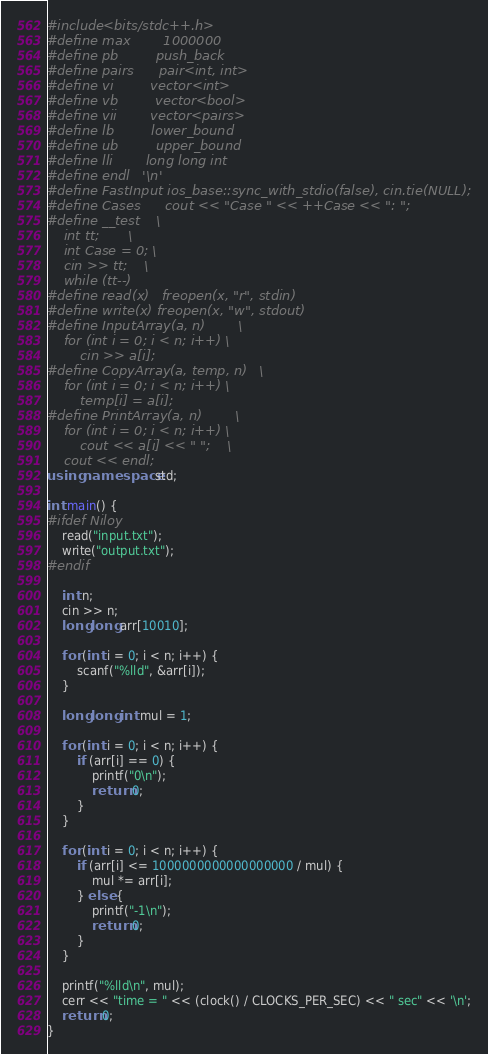<code> <loc_0><loc_0><loc_500><loc_500><_C++_>#include <bits/stdc++.h>
#define max		  1000000
#define pb		  push_back
#define pairs	  pair<int, int>
#define vi		  vector<int>
#define vb		  vector<bool>
#define vii		  vector<pairs>
#define lb		  lower_bound
#define ub		  upper_bound
#define lli		  long long int
#define endl	  '\n'
#define FastInput ios_base::sync_with_stdio(false), cin.tie(NULL);
#define Cases	  cout << "Case " << ++Case << ": ";
#define __test    \
	int tt;       \
	int Case = 0; \
	cin >> tt;    \
	while (tt--)
#define read(x)	 freopen(x, "r", stdin)
#define write(x) freopen(x, "w", stdout)
#define InputArray(a, n)        \
	for (int i = 0; i < n; i++) \
		cin >> a[i];
#define CopyArray(a, temp, n)   \
	for (int i = 0; i < n; i++) \
		temp[i] = a[i];
#define PrintArray(a, n)        \
	for (int i = 0; i < n; i++) \
		cout << a[i] << " ";    \
	cout << endl;
using namespace std;

int main() {
#ifdef Niloy
	read("input.txt");
	write("output.txt");
#endif

	int n;
	cin >> n;
	long long arr[10010];

	for (int i = 0; i < n; i++) {
		scanf("%lld", &arr[i]);
	}

	long long int mul = 1;

	for (int i = 0; i < n; i++) {
		if (arr[i] == 0) {
			printf("0\n");
			return 0;
		}
	}

	for (int i = 0; i < n; i++) {
		if (arr[i] <= 1000000000000000000 / mul) {
			mul *= arr[i];
		} else {
			printf("-1\n");
			return 0;
		}
	}

	printf("%lld\n", mul);
	cerr << "time = " << (clock() / CLOCKS_PER_SEC) << " sec" << '\n';
	return 0;
}</code> 